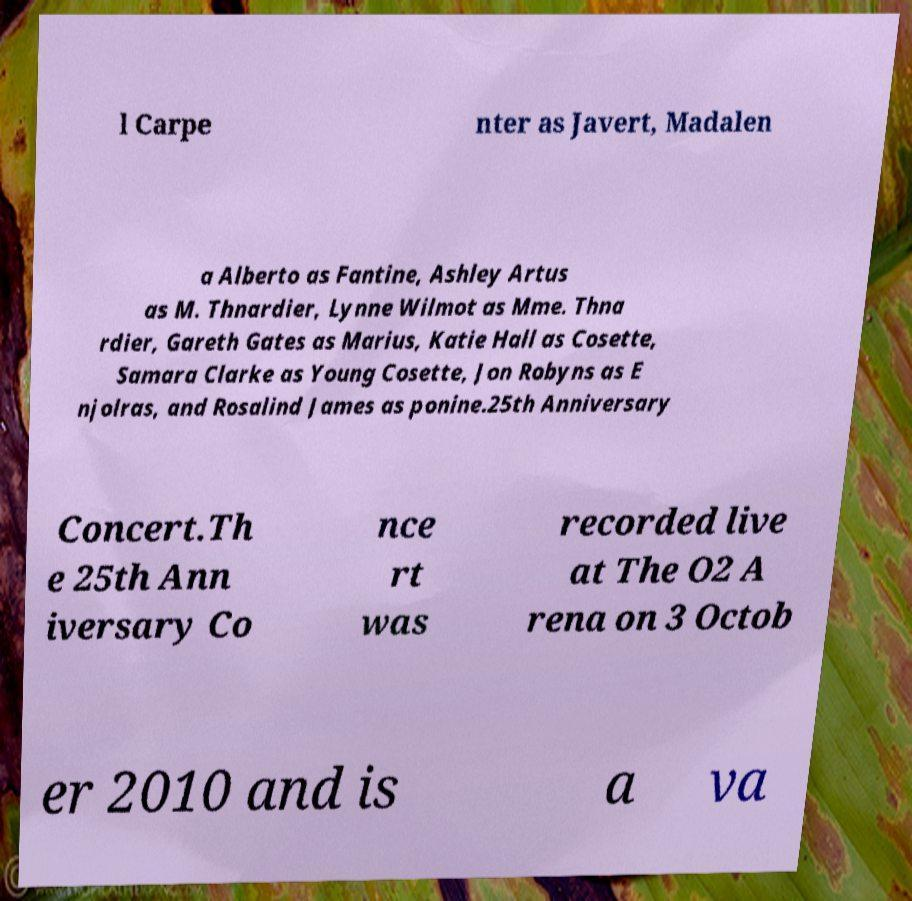What messages or text are displayed in this image? I need them in a readable, typed format. l Carpe nter as Javert, Madalen a Alberto as Fantine, Ashley Artus as M. Thnardier, Lynne Wilmot as Mme. Thna rdier, Gareth Gates as Marius, Katie Hall as Cosette, Samara Clarke as Young Cosette, Jon Robyns as E njolras, and Rosalind James as ponine.25th Anniversary Concert.Th e 25th Ann iversary Co nce rt was recorded live at The O2 A rena on 3 Octob er 2010 and is a va 